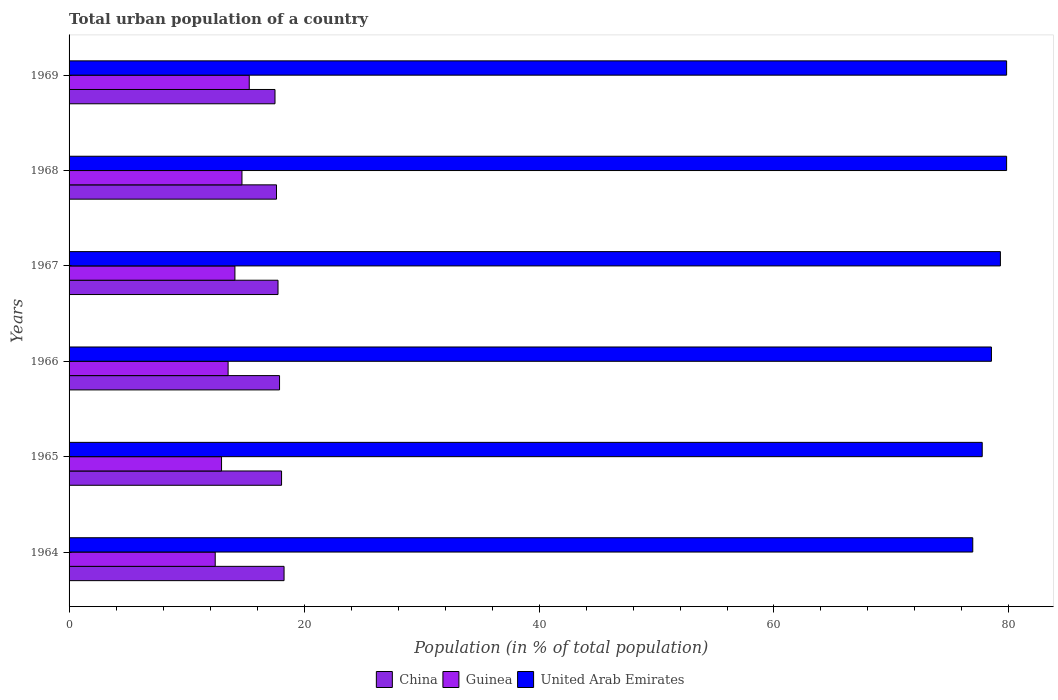How many different coloured bars are there?
Offer a terse response. 3. How many groups of bars are there?
Provide a succinct answer. 6. Are the number of bars per tick equal to the number of legend labels?
Your response must be concise. Yes. What is the label of the 1st group of bars from the top?
Provide a short and direct response. 1969. What is the urban population in United Arab Emirates in 1967?
Make the answer very short. 79.27. Across all years, what is the maximum urban population in China?
Your answer should be very brief. 18.3. Across all years, what is the minimum urban population in China?
Your answer should be very brief. 17.53. In which year was the urban population in Guinea maximum?
Ensure brevity in your answer.  1969. In which year was the urban population in China minimum?
Provide a succinct answer. 1969. What is the total urban population in Guinea in the graph?
Your answer should be compact. 83.12. What is the difference between the urban population in China in 1966 and that in 1969?
Keep it short and to the point. 0.39. What is the difference between the urban population in United Arab Emirates in 1967 and the urban population in China in 1968?
Give a very brief answer. 61.62. What is the average urban population in Guinea per year?
Make the answer very short. 13.85. In the year 1965, what is the difference between the urban population in United Arab Emirates and urban population in Guinea?
Give a very brief answer. 64.75. In how many years, is the urban population in China greater than 28 %?
Give a very brief answer. 0. What is the ratio of the urban population in United Arab Emirates in 1966 to that in 1967?
Your response must be concise. 0.99. Is the urban population in United Arab Emirates in 1967 less than that in 1968?
Make the answer very short. Yes. Is the difference between the urban population in United Arab Emirates in 1966 and 1968 greater than the difference between the urban population in Guinea in 1966 and 1968?
Your response must be concise. No. What is the difference between the highest and the second highest urban population in Guinea?
Offer a very short reply. 0.62. What is the difference between the highest and the lowest urban population in United Arab Emirates?
Your answer should be compact. 2.88. In how many years, is the urban population in United Arab Emirates greater than the average urban population in United Arab Emirates taken over all years?
Make the answer very short. 3. Is the sum of the urban population in Guinea in 1964 and 1967 greater than the maximum urban population in China across all years?
Offer a terse response. Yes. What does the 2nd bar from the bottom in 1964 represents?
Offer a very short reply. Guinea. Is it the case that in every year, the sum of the urban population in United Arab Emirates and urban population in Guinea is greater than the urban population in China?
Offer a terse response. Yes. How many bars are there?
Ensure brevity in your answer.  18. Are all the bars in the graph horizontal?
Your answer should be very brief. Yes. What is the difference between two consecutive major ticks on the X-axis?
Ensure brevity in your answer.  20. Does the graph contain grids?
Provide a succinct answer. No. Where does the legend appear in the graph?
Give a very brief answer. Bottom center. What is the title of the graph?
Make the answer very short. Total urban population of a country. Does "Costa Rica" appear as one of the legend labels in the graph?
Ensure brevity in your answer.  No. What is the label or title of the X-axis?
Your response must be concise. Population (in % of total population). What is the Population (in % of total population) in China in 1964?
Give a very brief answer. 18.3. What is the Population (in % of total population) in Guinea in 1964?
Your answer should be very brief. 12.44. What is the Population (in % of total population) in United Arab Emirates in 1964?
Make the answer very short. 76.92. What is the Population (in % of total population) in China in 1965?
Provide a succinct answer. 18.09. What is the Population (in % of total population) of Guinea in 1965?
Provide a succinct answer. 12.98. What is the Population (in % of total population) in United Arab Emirates in 1965?
Give a very brief answer. 77.72. What is the Population (in % of total population) in China in 1966?
Ensure brevity in your answer.  17.91. What is the Population (in % of total population) in Guinea in 1966?
Keep it short and to the point. 13.54. What is the Population (in % of total population) in United Arab Emirates in 1966?
Provide a short and direct response. 78.51. What is the Population (in % of total population) of China in 1967?
Give a very brief answer. 17.79. What is the Population (in % of total population) in Guinea in 1967?
Provide a succinct answer. 14.12. What is the Population (in % of total population) in United Arab Emirates in 1967?
Provide a short and direct response. 79.27. What is the Population (in % of total population) of China in 1968?
Ensure brevity in your answer.  17.66. What is the Population (in % of total population) in Guinea in 1968?
Give a very brief answer. 14.72. What is the Population (in % of total population) in United Arab Emirates in 1968?
Your answer should be compact. 79.8. What is the Population (in % of total population) of China in 1969?
Give a very brief answer. 17.53. What is the Population (in % of total population) of Guinea in 1969?
Keep it short and to the point. 15.34. What is the Population (in % of total population) of United Arab Emirates in 1969?
Offer a very short reply. 79.8. Across all years, what is the maximum Population (in % of total population) in China?
Provide a succinct answer. 18.3. Across all years, what is the maximum Population (in % of total population) of Guinea?
Make the answer very short. 15.34. Across all years, what is the maximum Population (in % of total population) of United Arab Emirates?
Offer a very short reply. 79.8. Across all years, what is the minimum Population (in % of total population) in China?
Make the answer very short. 17.53. Across all years, what is the minimum Population (in % of total population) in Guinea?
Provide a short and direct response. 12.44. Across all years, what is the minimum Population (in % of total population) in United Arab Emirates?
Provide a succinct answer. 76.92. What is the total Population (in % of total population) of China in the graph?
Your answer should be compact. 107.27. What is the total Population (in % of total population) of Guinea in the graph?
Make the answer very short. 83.12. What is the total Population (in % of total population) in United Arab Emirates in the graph?
Make the answer very short. 472.02. What is the difference between the Population (in % of total population) of China in 1964 and that in 1965?
Give a very brief answer. 0.21. What is the difference between the Population (in % of total population) of Guinea in 1964 and that in 1965?
Offer a terse response. -0.54. What is the difference between the Population (in % of total population) in United Arab Emirates in 1964 and that in 1965?
Offer a terse response. -0.8. What is the difference between the Population (in % of total population) of China in 1964 and that in 1966?
Make the answer very short. 0.38. What is the difference between the Population (in % of total population) of Guinea in 1964 and that in 1966?
Make the answer very short. -1.1. What is the difference between the Population (in % of total population) of United Arab Emirates in 1964 and that in 1966?
Your answer should be very brief. -1.59. What is the difference between the Population (in % of total population) of China in 1964 and that in 1967?
Give a very brief answer. 0.51. What is the difference between the Population (in % of total population) of Guinea in 1964 and that in 1967?
Make the answer very short. -1.68. What is the difference between the Population (in % of total population) in United Arab Emirates in 1964 and that in 1967?
Your response must be concise. -2.35. What is the difference between the Population (in % of total population) in China in 1964 and that in 1968?
Give a very brief answer. 0.64. What is the difference between the Population (in % of total population) in Guinea in 1964 and that in 1968?
Give a very brief answer. -2.28. What is the difference between the Population (in % of total population) in United Arab Emirates in 1964 and that in 1968?
Your response must be concise. -2.88. What is the difference between the Population (in % of total population) in China in 1964 and that in 1969?
Give a very brief answer. 0.77. What is the difference between the Population (in % of total population) in Guinea in 1964 and that in 1969?
Provide a succinct answer. -2.9. What is the difference between the Population (in % of total population) in United Arab Emirates in 1964 and that in 1969?
Give a very brief answer. -2.88. What is the difference between the Population (in % of total population) of China in 1965 and that in 1966?
Provide a succinct answer. 0.17. What is the difference between the Population (in % of total population) in Guinea in 1965 and that in 1966?
Give a very brief answer. -0.56. What is the difference between the Population (in % of total population) in United Arab Emirates in 1965 and that in 1966?
Offer a terse response. -0.79. What is the difference between the Population (in % of total population) of China in 1965 and that in 1967?
Give a very brief answer. 0.3. What is the difference between the Population (in % of total population) of Guinea in 1965 and that in 1967?
Give a very brief answer. -1.14. What is the difference between the Population (in % of total population) of United Arab Emirates in 1965 and that in 1967?
Give a very brief answer. -1.55. What is the difference between the Population (in % of total population) in China in 1965 and that in 1968?
Your response must be concise. 0.43. What is the difference between the Population (in % of total population) in Guinea in 1965 and that in 1968?
Provide a short and direct response. -1.74. What is the difference between the Population (in % of total population) in United Arab Emirates in 1965 and that in 1968?
Your answer should be very brief. -2.08. What is the difference between the Population (in % of total population) in China in 1965 and that in 1969?
Offer a very short reply. 0.56. What is the difference between the Population (in % of total population) in Guinea in 1965 and that in 1969?
Provide a succinct answer. -2.36. What is the difference between the Population (in % of total population) in United Arab Emirates in 1965 and that in 1969?
Offer a very short reply. -2.08. What is the difference between the Population (in % of total population) in China in 1966 and that in 1967?
Your response must be concise. 0.13. What is the difference between the Population (in % of total population) in Guinea in 1966 and that in 1967?
Offer a terse response. -0.58. What is the difference between the Population (in % of total population) in United Arab Emirates in 1966 and that in 1967?
Your response must be concise. -0.76. What is the difference between the Population (in % of total population) of China in 1966 and that in 1968?
Give a very brief answer. 0.26. What is the difference between the Population (in % of total population) in Guinea in 1966 and that in 1968?
Your answer should be very brief. -1.18. What is the difference between the Population (in % of total population) of United Arab Emirates in 1966 and that in 1968?
Your response must be concise. -1.29. What is the difference between the Population (in % of total population) of China in 1966 and that in 1969?
Offer a terse response. 0.39. What is the difference between the Population (in % of total population) of Guinea in 1966 and that in 1969?
Your answer should be compact. -1.8. What is the difference between the Population (in % of total population) in United Arab Emirates in 1966 and that in 1969?
Provide a short and direct response. -1.29. What is the difference between the Population (in % of total population) of China in 1967 and that in 1968?
Offer a terse response. 0.13. What is the difference between the Population (in % of total population) of Guinea in 1967 and that in 1968?
Your answer should be compact. -0.6. What is the difference between the Population (in % of total population) in United Arab Emirates in 1967 and that in 1968?
Offer a very short reply. -0.53. What is the difference between the Population (in % of total population) in China in 1967 and that in 1969?
Make the answer very short. 0.26. What is the difference between the Population (in % of total population) in Guinea in 1967 and that in 1969?
Give a very brief answer. -1.22. What is the difference between the Population (in % of total population) of United Arab Emirates in 1967 and that in 1969?
Your answer should be very brief. -0.53. What is the difference between the Population (in % of total population) in China in 1968 and that in 1969?
Offer a very short reply. 0.13. What is the difference between the Population (in % of total population) in Guinea in 1968 and that in 1969?
Provide a succinct answer. -0.62. What is the difference between the Population (in % of total population) in China in 1964 and the Population (in % of total population) in Guinea in 1965?
Keep it short and to the point. 5.32. What is the difference between the Population (in % of total population) in China in 1964 and the Population (in % of total population) in United Arab Emirates in 1965?
Give a very brief answer. -59.42. What is the difference between the Population (in % of total population) of Guinea in 1964 and the Population (in % of total population) of United Arab Emirates in 1965?
Your answer should be compact. -65.28. What is the difference between the Population (in % of total population) of China in 1964 and the Population (in % of total population) of Guinea in 1966?
Give a very brief answer. 4.76. What is the difference between the Population (in % of total population) in China in 1964 and the Population (in % of total population) in United Arab Emirates in 1966?
Provide a succinct answer. -60.21. What is the difference between the Population (in % of total population) of Guinea in 1964 and the Population (in % of total population) of United Arab Emirates in 1966?
Your answer should be very brief. -66.07. What is the difference between the Population (in % of total population) in China in 1964 and the Population (in % of total population) in Guinea in 1967?
Your response must be concise. 4.18. What is the difference between the Population (in % of total population) in China in 1964 and the Population (in % of total population) in United Arab Emirates in 1967?
Give a very brief answer. -60.97. What is the difference between the Population (in % of total population) of Guinea in 1964 and the Population (in % of total population) of United Arab Emirates in 1967?
Keep it short and to the point. -66.83. What is the difference between the Population (in % of total population) in China in 1964 and the Population (in % of total population) in Guinea in 1968?
Provide a short and direct response. 3.58. What is the difference between the Population (in % of total population) in China in 1964 and the Population (in % of total population) in United Arab Emirates in 1968?
Offer a very short reply. -61.5. What is the difference between the Population (in % of total population) in Guinea in 1964 and the Population (in % of total population) in United Arab Emirates in 1968?
Offer a very short reply. -67.36. What is the difference between the Population (in % of total population) of China in 1964 and the Population (in % of total population) of Guinea in 1969?
Provide a short and direct response. 2.96. What is the difference between the Population (in % of total population) of China in 1964 and the Population (in % of total population) of United Arab Emirates in 1969?
Keep it short and to the point. -61.5. What is the difference between the Population (in % of total population) in Guinea in 1964 and the Population (in % of total population) in United Arab Emirates in 1969?
Offer a very short reply. -67.36. What is the difference between the Population (in % of total population) of China in 1965 and the Population (in % of total population) of Guinea in 1966?
Ensure brevity in your answer.  4.55. What is the difference between the Population (in % of total population) of China in 1965 and the Population (in % of total population) of United Arab Emirates in 1966?
Your answer should be very brief. -60.42. What is the difference between the Population (in % of total population) of Guinea in 1965 and the Population (in % of total population) of United Arab Emirates in 1966?
Provide a succinct answer. -65.53. What is the difference between the Population (in % of total population) in China in 1965 and the Population (in % of total population) in Guinea in 1967?
Your answer should be very brief. 3.97. What is the difference between the Population (in % of total population) in China in 1965 and the Population (in % of total population) in United Arab Emirates in 1967?
Offer a very short reply. -61.19. What is the difference between the Population (in % of total population) of Guinea in 1965 and the Population (in % of total population) of United Arab Emirates in 1967?
Provide a succinct answer. -66.29. What is the difference between the Population (in % of total population) of China in 1965 and the Population (in % of total population) of Guinea in 1968?
Offer a terse response. 3.37. What is the difference between the Population (in % of total population) of China in 1965 and the Population (in % of total population) of United Arab Emirates in 1968?
Offer a terse response. -61.71. What is the difference between the Population (in % of total population) of Guinea in 1965 and the Population (in % of total population) of United Arab Emirates in 1968?
Your answer should be compact. -66.82. What is the difference between the Population (in % of total population) in China in 1965 and the Population (in % of total population) in Guinea in 1969?
Keep it short and to the point. 2.75. What is the difference between the Population (in % of total population) of China in 1965 and the Population (in % of total population) of United Arab Emirates in 1969?
Provide a succinct answer. -61.71. What is the difference between the Population (in % of total population) of Guinea in 1965 and the Population (in % of total population) of United Arab Emirates in 1969?
Offer a terse response. -66.82. What is the difference between the Population (in % of total population) in China in 1966 and the Population (in % of total population) in Guinea in 1967?
Provide a succinct answer. 3.8. What is the difference between the Population (in % of total population) in China in 1966 and the Population (in % of total population) in United Arab Emirates in 1967?
Ensure brevity in your answer.  -61.36. What is the difference between the Population (in % of total population) in Guinea in 1966 and the Population (in % of total population) in United Arab Emirates in 1967?
Ensure brevity in your answer.  -65.73. What is the difference between the Population (in % of total population) in China in 1966 and the Population (in % of total population) in Guinea in 1968?
Provide a short and direct response. 3.2. What is the difference between the Population (in % of total population) of China in 1966 and the Population (in % of total population) of United Arab Emirates in 1968?
Ensure brevity in your answer.  -61.88. What is the difference between the Population (in % of total population) in Guinea in 1966 and the Population (in % of total population) in United Arab Emirates in 1968?
Your response must be concise. -66.26. What is the difference between the Population (in % of total population) in China in 1966 and the Population (in % of total population) in Guinea in 1969?
Your answer should be very brief. 2.58. What is the difference between the Population (in % of total population) in China in 1966 and the Population (in % of total population) in United Arab Emirates in 1969?
Give a very brief answer. -61.88. What is the difference between the Population (in % of total population) in Guinea in 1966 and the Population (in % of total population) in United Arab Emirates in 1969?
Keep it short and to the point. -66.26. What is the difference between the Population (in % of total population) in China in 1967 and the Population (in % of total population) in Guinea in 1968?
Make the answer very short. 3.07. What is the difference between the Population (in % of total population) in China in 1967 and the Population (in % of total population) in United Arab Emirates in 1968?
Ensure brevity in your answer.  -62.02. What is the difference between the Population (in % of total population) in Guinea in 1967 and the Population (in % of total population) in United Arab Emirates in 1968?
Provide a succinct answer. -65.68. What is the difference between the Population (in % of total population) in China in 1967 and the Population (in % of total population) in Guinea in 1969?
Your answer should be compact. 2.45. What is the difference between the Population (in % of total population) of China in 1967 and the Population (in % of total population) of United Arab Emirates in 1969?
Give a very brief answer. -62.02. What is the difference between the Population (in % of total population) of Guinea in 1967 and the Population (in % of total population) of United Arab Emirates in 1969?
Offer a terse response. -65.68. What is the difference between the Population (in % of total population) in China in 1968 and the Population (in % of total population) in Guinea in 1969?
Ensure brevity in your answer.  2.32. What is the difference between the Population (in % of total population) of China in 1968 and the Population (in % of total population) of United Arab Emirates in 1969?
Make the answer very short. -62.14. What is the difference between the Population (in % of total population) in Guinea in 1968 and the Population (in % of total population) in United Arab Emirates in 1969?
Your response must be concise. -65.08. What is the average Population (in % of total population) in China per year?
Offer a terse response. 17.88. What is the average Population (in % of total population) of Guinea per year?
Your response must be concise. 13.85. What is the average Population (in % of total population) of United Arab Emirates per year?
Make the answer very short. 78.67. In the year 1964, what is the difference between the Population (in % of total population) in China and Population (in % of total population) in Guinea?
Your answer should be compact. 5.86. In the year 1964, what is the difference between the Population (in % of total population) of China and Population (in % of total population) of United Arab Emirates?
Your answer should be very brief. -58.62. In the year 1964, what is the difference between the Population (in % of total population) in Guinea and Population (in % of total population) in United Arab Emirates?
Make the answer very short. -64.48. In the year 1965, what is the difference between the Population (in % of total population) of China and Population (in % of total population) of Guinea?
Make the answer very short. 5.11. In the year 1965, what is the difference between the Population (in % of total population) of China and Population (in % of total population) of United Arab Emirates?
Offer a terse response. -59.64. In the year 1965, what is the difference between the Population (in % of total population) of Guinea and Population (in % of total population) of United Arab Emirates?
Provide a short and direct response. -64.75. In the year 1966, what is the difference between the Population (in % of total population) of China and Population (in % of total population) of Guinea?
Provide a short and direct response. 4.38. In the year 1966, what is the difference between the Population (in % of total population) in China and Population (in % of total population) in United Arab Emirates?
Your answer should be compact. -60.59. In the year 1966, what is the difference between the Population (in % of total population) of Guinea and Population (in % of total population) of United Arab Emirates?
Give a very brief answer. -64.97. In the year 1967, what is the difference between the Population (in % of total population) in China and Population (in % of total population) in Guinea?
Your answer should be compact. 3.67. In the year 1967, what is the difference between the Population (in % of total population) of China and Population (in % of total population) of United Arab Emirates?
Ensure brevity in your answer.  -61.49. In the year 1967, what is the difference between the Population (in % of total population) in Guinea and Population (in % of total population) in United Arab Emirates?
Provide a short and direct response. -65.16. In the year 1968, what is the difference between the Population (in % of total population) in China and Population (in % of total population) in Guinea?
Provide a succinct answer. 2.94. In the year 1968, what is the difference between the Population (in % of total population) of China and Population (in % of total population) of United Arab Emirates?
Give a very brief answer. -62.14. In the year 1968, what is the difference between the Population (in % of total population) in Guinea and Population (in % of total population) in United Arab Emirates?
Your answer should be compact. -65.08. In the year 1969, what is the difference between the Population (in % of total population) of China and Population (in % of total population) of Guinea?
Your answer should be compact. 2.19. In the year 1969, what is the difference between the Population (in % of total population) of China and Population (in % of total population) of United Arab Emirates?
Offer a very short reply. -62.27. In the year 1969, what is the difference between the Population (in % of total population) of Guinea and Population (in % of total population) of United Arab Emirates?
Ensure brevity in your answer.  -64.46. What is the ratio of the Population (in % of total population) of China in 1964 to that in 1965?
Make the answer very short. 1.01. What is the ratio of the Population (in % of total population) of Guinea in 1964 to that in 1965?
Your answer should be very brief. 0.96. What is the ratio of the Population (in % of total population) in China in 1964 to that in 1966?
Provide a short and direct response. 1.02. What is the ratio of the Population (in % of total population) in Guinea in 1964 to that in 1966?
Your answer should be very brief. 0.92. What is the ratio of the Population (in % of total population) of United Arab Emirates in 1964 to that in 1966?
Your answer should be very brief. 0.98. What is the ratio of the Population (in % of total population) in China in 1964 to that in 1967?
Provide a succinct answer. 1.03. What is the ratio of the Population (in % of total population) in Guinea in 1964 to that in 1967?
Make the answer very short. 0.88. What is the ratio of the Population (in % of total population) of United Arab Emirates in 1964 to that in 1967?
Provide a succinct answer. 0.97. What is the ratio of the Population (in % of total population) in China in 1964 to that in 1968?
Offer a very short reply. 1.04. What is the ratio of the Population (in % of total population) of Guinea in 1964 to that in 1968?
Make the answer very short. 0.85. What is the ratio of the Population (in % of total population) in United Arab Emirates in 1964 to that in 1968?
Provide a short and direct response. 0.96. What is the ratio of the Population (in % of total population) in China in 1964 to that in 1969?
Provide a succinct answer. 1.04. What is the ratio of the Population (in % of total population) in Guinea in 1964 to that in 1969?
Your answer should be compact. 0.81. What is the ratio of the Population (in % of total population) of United Arab Emirates in 1964 to that in 1969?
Provide a short and direct response. 0.96. What is the ratio of the Population (in % of total population) in China in 1965 to that in 1966?
Offer a very short reply. 1.01. What is the ratio of the Population (in % of total population) in Guinea in 1965 to that in 1966?
Offer a terse response. 0.96. What is the ratio of the Population (in % of total population) in China in 1965 to that in 1967?
Offer a terse response. 1.02. What is the ratio of the Population (in % of total population) of Guinea in 1965 to that in 1967?
Your answer should be very brief. 0.92. What is the ratio of the Population (in % of total population) of United Arab Emirates in 1965 to that in 1967?
Make the answer very short. 0.98. What is the ratio of the Population (in % of total population) in China in 1965 to that in 1968?
Keep it short and to the point. 1.02. What is the ratio of the Population (in % of total population) of Guinea in 1965 to that in 1968?
Ensure brevity in your answer.  0.88. What is the ratio of the Population (in % of total population) in United Arab Emirates in 1965 to that in 1968?
Give a very brief answer. 0.97. What is the ratio of the Population (in % of total population) of China in 1965 to that in 1969?
Keep it short and to the point. 1.03. What is the ratio of the Population (in % of total population) of Guinea in 1965 to that in 1969?
Your response must be concise. 0.85. What is the ratio of the Population (in % of total population) in United Arab Emirates in 1965 to that in 1969?
Give a very brief answer. 0.97. What is the ratio of the Population (in % of total population) of China in 1966 to that in 1967?
Ensure brevity in your answer.  1.01. What is the ratio of the Population (in % of total population) in Guinea in 1966 to that in 1967?
Your answer should be compact. 0.96. What is the ratio of the Population (in % of total population) of United Arab Emirates in 1966 to that in 1967?
Make the answer very short. 0.99. What is the ratio of the Population (in % of total population) in China in 1966 to that in 1968?
Provide a short and direct response. 1.01. What is the ratio of the Population (in % of total population) in Guinea in 1966 to that in 1968?
Your answer should be compact. 0.92. What is the ratio of the Population (in % of total population) in United Arab Emirates in 1966 to that in 1968?
Your response must be concise. 0.98. What is the ratio of the Population (in % of total population) in China in 1966 to that in 1969?
Give a very brief answer. 1.02. What is the ratio of the Population (in % of total population) in Guinea in 1966 to that in 1969?
Your answer should be compact. 0.88. What is the ratio of the Population (in % of total population) of United Arab Emirates in 1966 to that in 1969?
Provide a short and direct response. 0.98. What is the ratio of the Population (in % of total population) in China in 1967 to that in 1968?
Provide a short and direct response. 1.01. What is the ratio of the Population (in % of total population) of Guinea in 1967 to that in 1968?
Ensure brevity in your answer.  0.96. What is the ratio of the Population (in % of total population) in United Arab Emirates in 1967 to that in 1968?
Offer a very short reply. 0.99. What is the ratio of the Population (in % of total population) in China in 1967 to that in 1969?
Keep it short and to the point. 1.01. What is the ratio of the Population (in % of total population) in Guinea in 1967 to that in 1969?
Your response must be concise. 0.92. What is the ratio of the Population (in % of total population) in China in 1968 to that in 1969?
Provide a short and direct response. 1.01. What is the ratio of the Population (in % of total population) in Guinea in 1968 to that in 1969?
Provide a succinct answer. 0.96. What is the difference between the highest and the second highest Population (in % of total population) in China?
Your answer should be very brief. 0.21. What is the difference between the highest and the second highest Population (in % of total population) of Guinea?
Your response must be concise. 0.62. What is the difference between the highest and the second highest Population (in % of total population) of United Arab Emirates?
Your answer should be compact. 0. What is the difference between the highest and the lowest Population (in % of total population) in China?
Offer a very short reply. 0.77. What is the difference between the highest and the lowest Population (in % of total population) of Guinea?
Your response must be concise. 2.9. What is the difference between the highest and the lowest Population (in % of total population) in United Arab Emirates?
Your answer should be very brief. 2.88. 